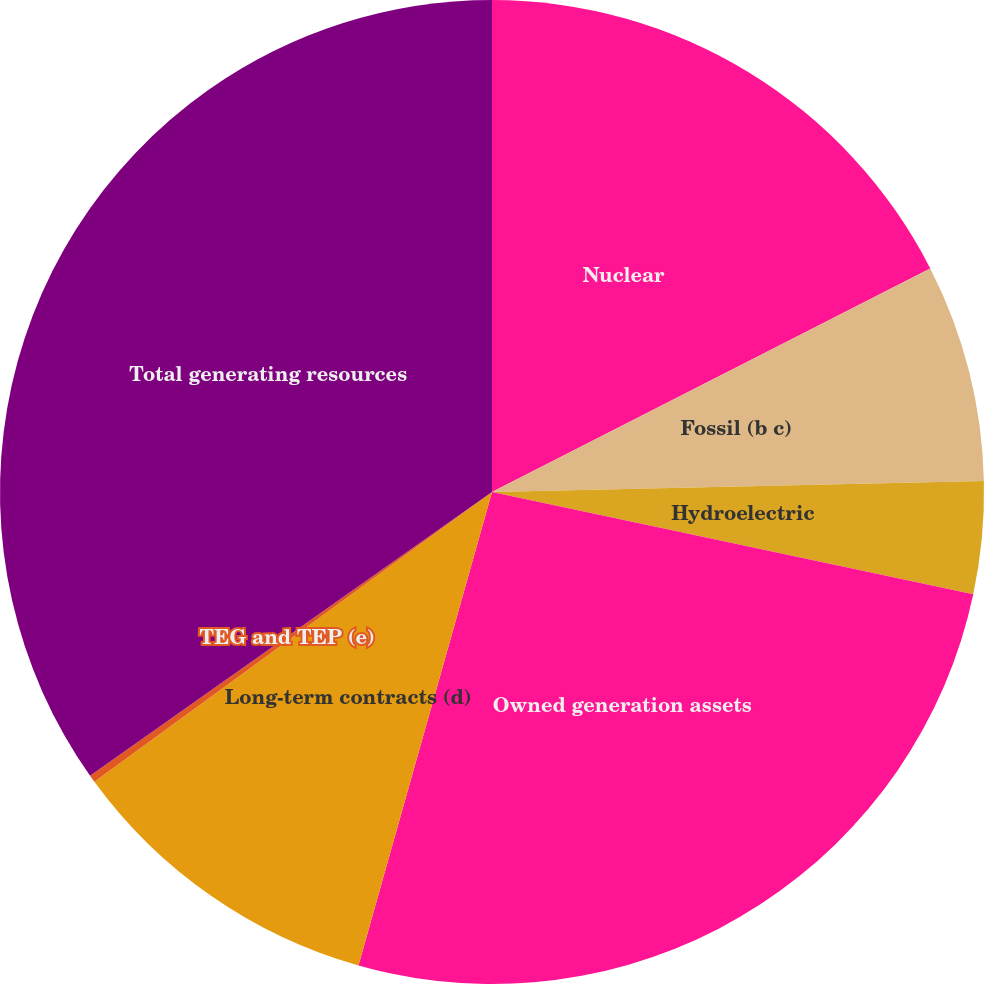Convert chart to OTSL. <chart><loc_0><loc_0><loc_500><loc_500><pie_chart><fcel>Nuclear<fcel>Fossil (b c)<fcel>Hydroelectric<fcel>Owned generation assets<fcel>Long-term contracts (d)<fcel>TEG and TEP (e)<fcel>Total generating resources<nl><fcel>17.49%<fcel>7.15%<fcel>3.69%<fcel>26.04%<fcel>10.6%<fcel>0.24%<fcel>34.78%<nl></chart> 